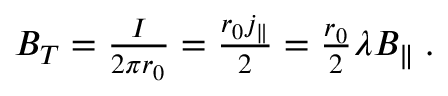Convert formula to latex. <formula><loc_0><loc_0><loc_500><loc_500>\begin{array} { r } { B _ { T } = \frac { I } { 2 \pi r _ { 0 } } = \frac { r _ { 0 } j _ { \| } } { 2 } = \frac { r _ { 0 } } { 2 } \lambda B _ { \| } \, . } \end{array}</formula> 